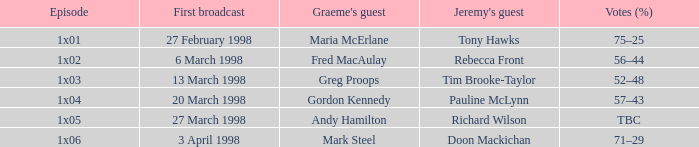What is Graeme's Guest, when Episode is "1x03"? Greg Proops. 